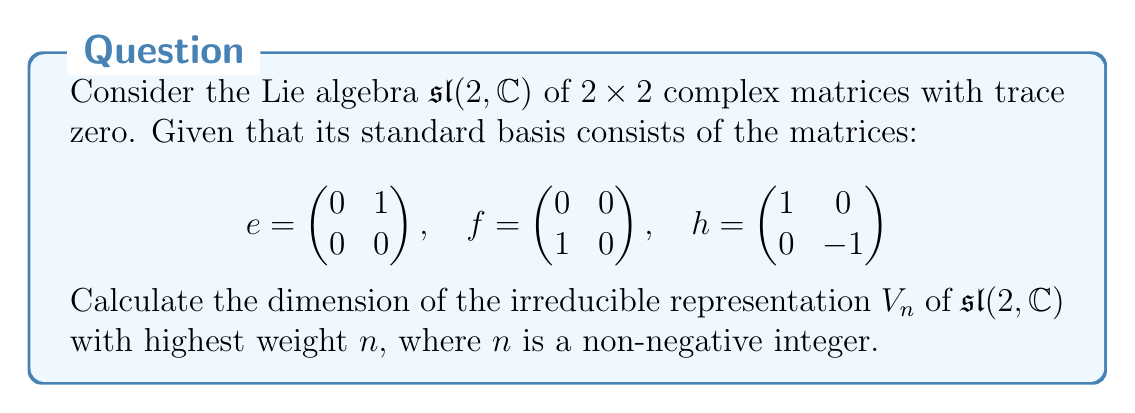Provide a solution to this math problem. To solve this problem, we'll follow these steps:

1) In the representation theory of $\mathfrak{sl}(2, \mathbb{C})$, the irreducible representations are parameterized by their highest weights, which are non-negative integers.

2) The highest weight $n$ corresponds to the eigenvalue of the $h$ matrix on the highest weight vector.

3) The structure of $\mathfrak{sl}(2, \mathbb{C})$ representations is such that starting from the highest weight vector, we can apply the lowering operator $f$ repeatedly to obtain a chain of weight vectors.

4) Each application of $f$ decreases the weight by 2, and this process continues until we reach the lowest weight vector.

5) The weights in the representation $V_n$ are $n, n-2, n-4, ..., -n+2, -n$.

6) To count the number of weight vectors (which gives us the dimension), we need to count how many integers are in this sequence.

7) The number of integers in an arithmetic sequence from $n$ to $-n$ with step -2 is:

   $\frac{n - (-n)}{2} + 1 = \frac{2n}{2} + 1 = n + 1$

Therefore, the dimension of the irreducible representation $V_n$ is $n + 1$.

This result is particularly relevant for software developers working on computational algebra systems or quantum computing simulations, where representations of Lie algebras often play a crucial role.
Answer: $n + 1$ 